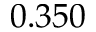<formula> <loc_0><loc_0><loc_500><loc_500>0 . 3 5 0</formula> 